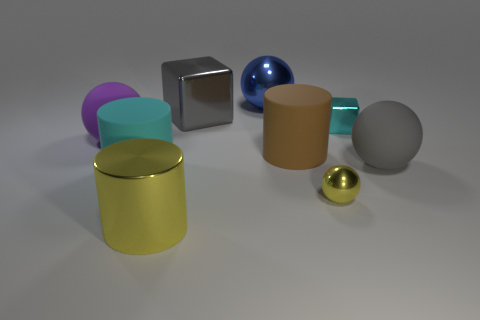What number of other objects are the same color as the big shiny sphere?
Your response must be concise. 0. There is a big gray thing behind the big rubber sphere in front of the big purple ball that is on the left side of the yellow shiny ball; what shape is it?
Keep it short and to the point. Cube. What is the material of the cyan thing that is in front of the big matte ball that is left of the big gray cube?
Provide a short and direct response. Rubber. There is a gray object that is made of the same material as the big yellow cylinder; what is its shape?
Give a very brief answer. Cube. There is a tiny sphere; how many cyan objects are on the left side of it?
Keep it short and to the point. 1. Are any purple cubes visible?
Your answer should be very brief. No. What is the color of the big rubber thing on the right side of the matte cylinder that is behind the matte sphere on the right side of the purple object?
Keep it short and to the point. Gray. Is there a cyan cylinder that is in front of the large gray object that is left of the tiny shiny cube?
Your answer should be compact. Yes. Is the color of the block that is left of the tiny cyan cube the same as the rubber sphere in front of the large purple sphere?
Offer a very short reply. Yes. What number of gray rubber balls have the same size as the brown matte cylinder?
Offer a terse response. 1. 